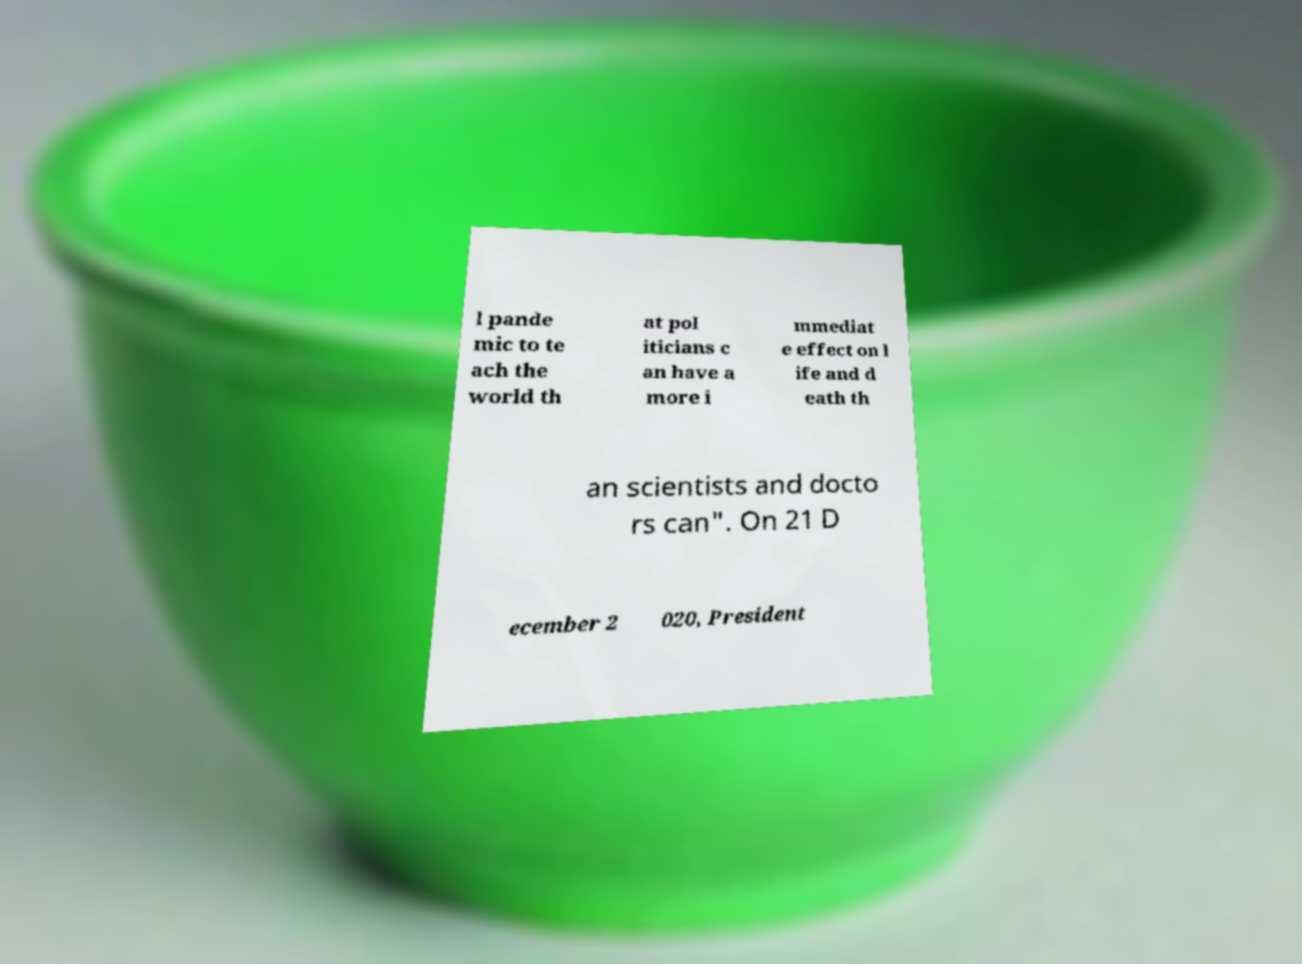For documentation purposes, I need the text within this image transcribed. Could you provide that? l pande mic to te ach the world th at pol iticians c an have a more i mmediat e effect on l ife and d eath th an scientists and docto rs can". On 21 D ecember 2 020, President 